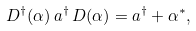Convert formula to latex. <formula><loc_0><loc_0><loc_500><loc_500>D ^ { \dagger } ( \alpha ) \, a ^ { \dagger } \, D ( \alpha ) = a ^ { \dagger } + \alpha ^ { \ast } ,</formula> 